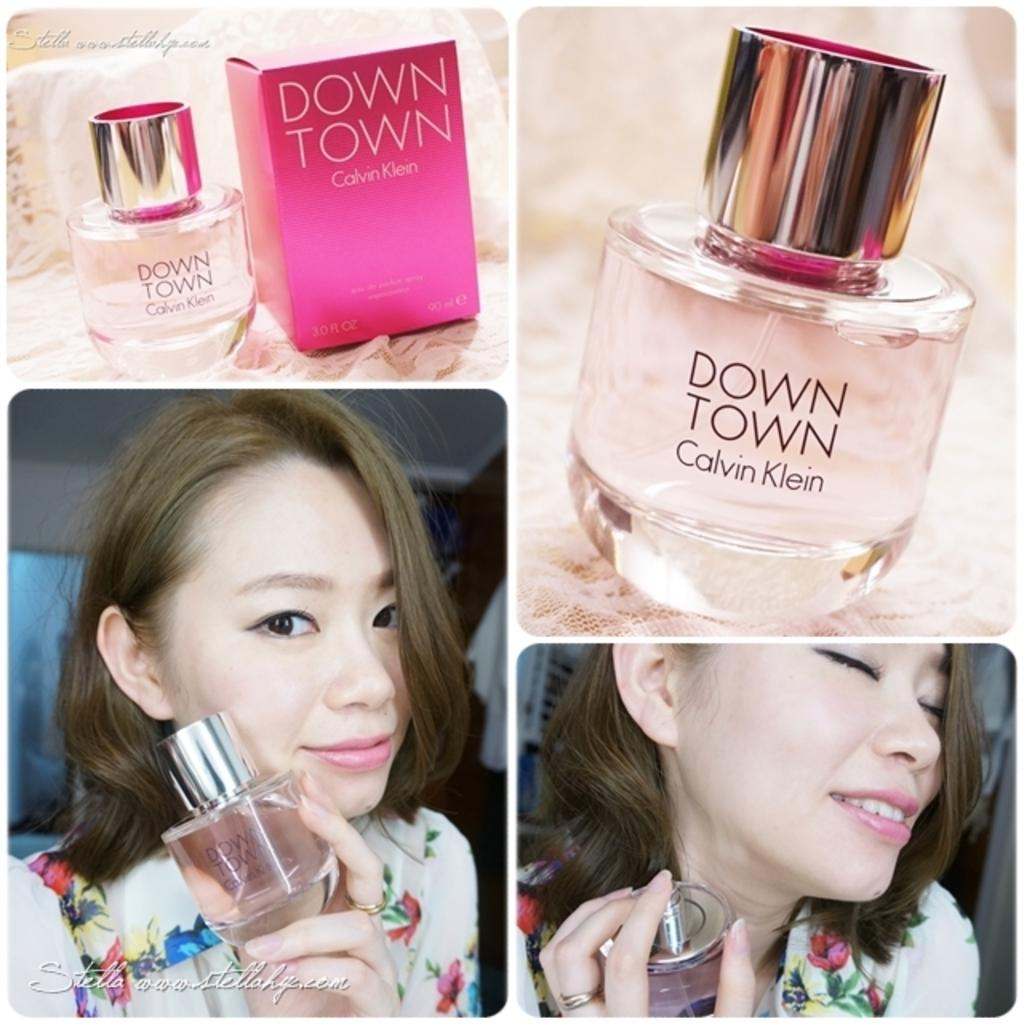<image>
Summarize the visual content of the image. A woman holds a bottle of Down Town perfume by Calvin Klein. 